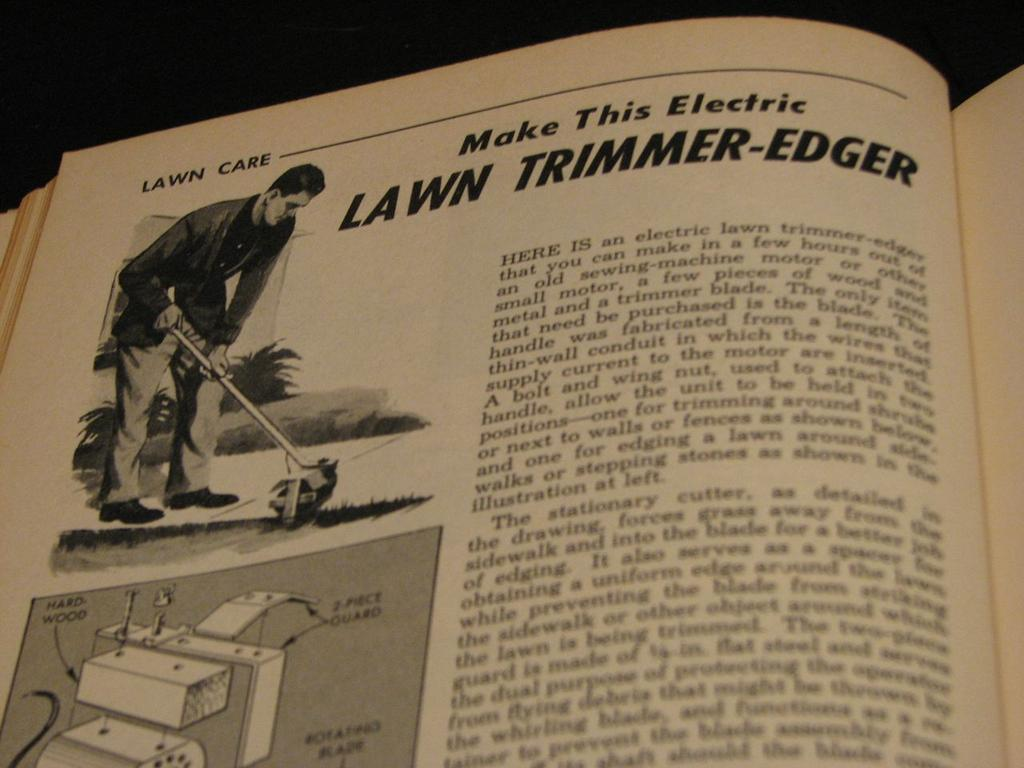<image>
Present a compact description of the photo's key features. The page of a book explaining how to make an electric lawn trimmer-edger. 